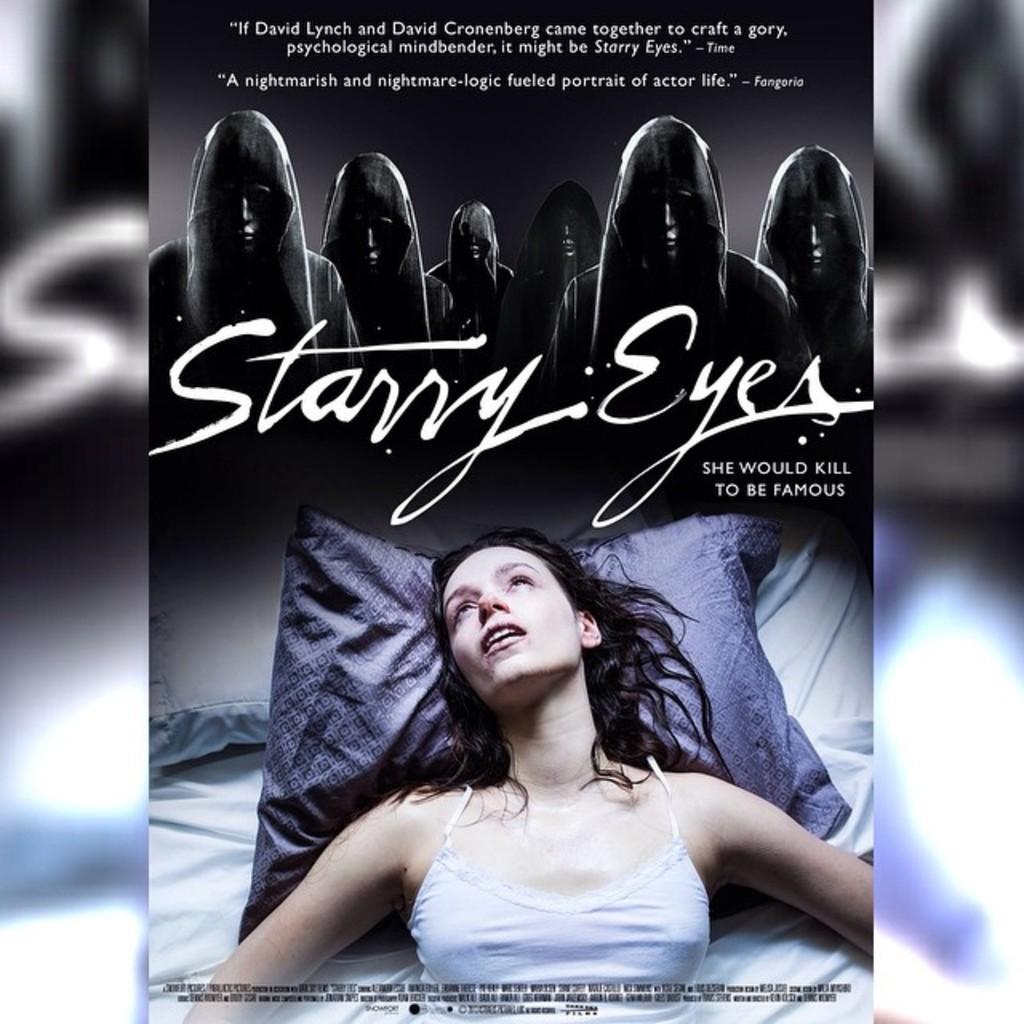Can you describe this image briefly? In the foreground of this poster, there is a woman lying on the bed. On the top, there is some text and few persons wearing hoodies and also a text written as "STARRY EYES" and the background is blurred. 